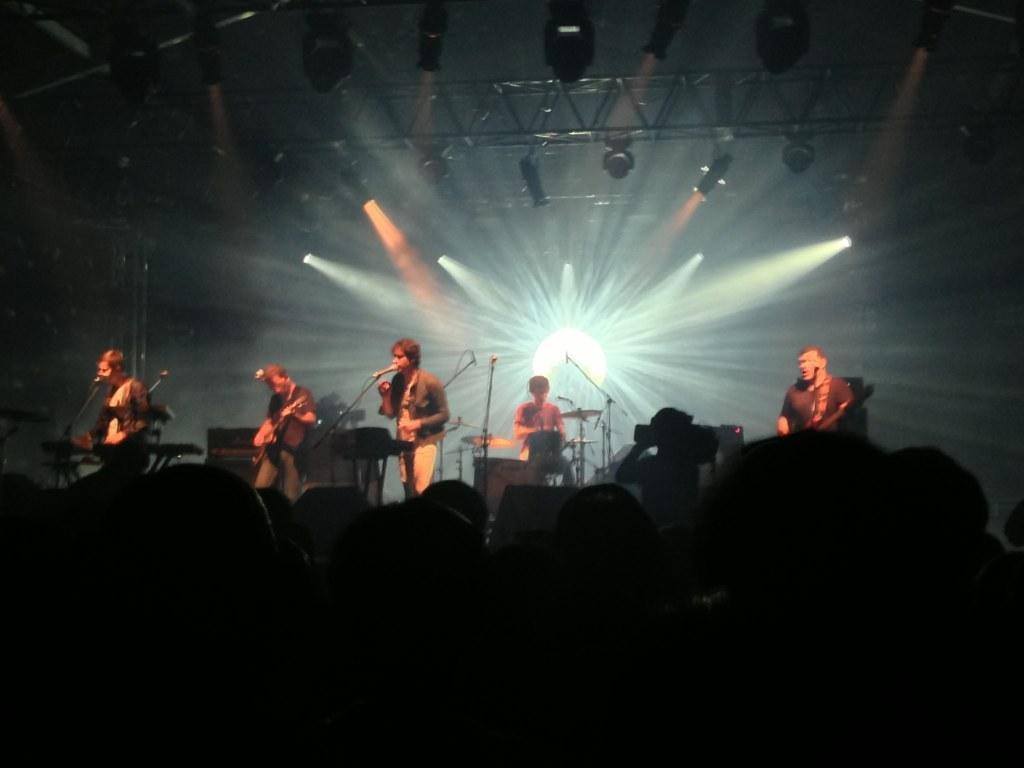Could you give a brief overview of what you see in this image? In the center of the image there are people performing a concert. At the bottom of the image there are people. In the background of the image there are lights. 